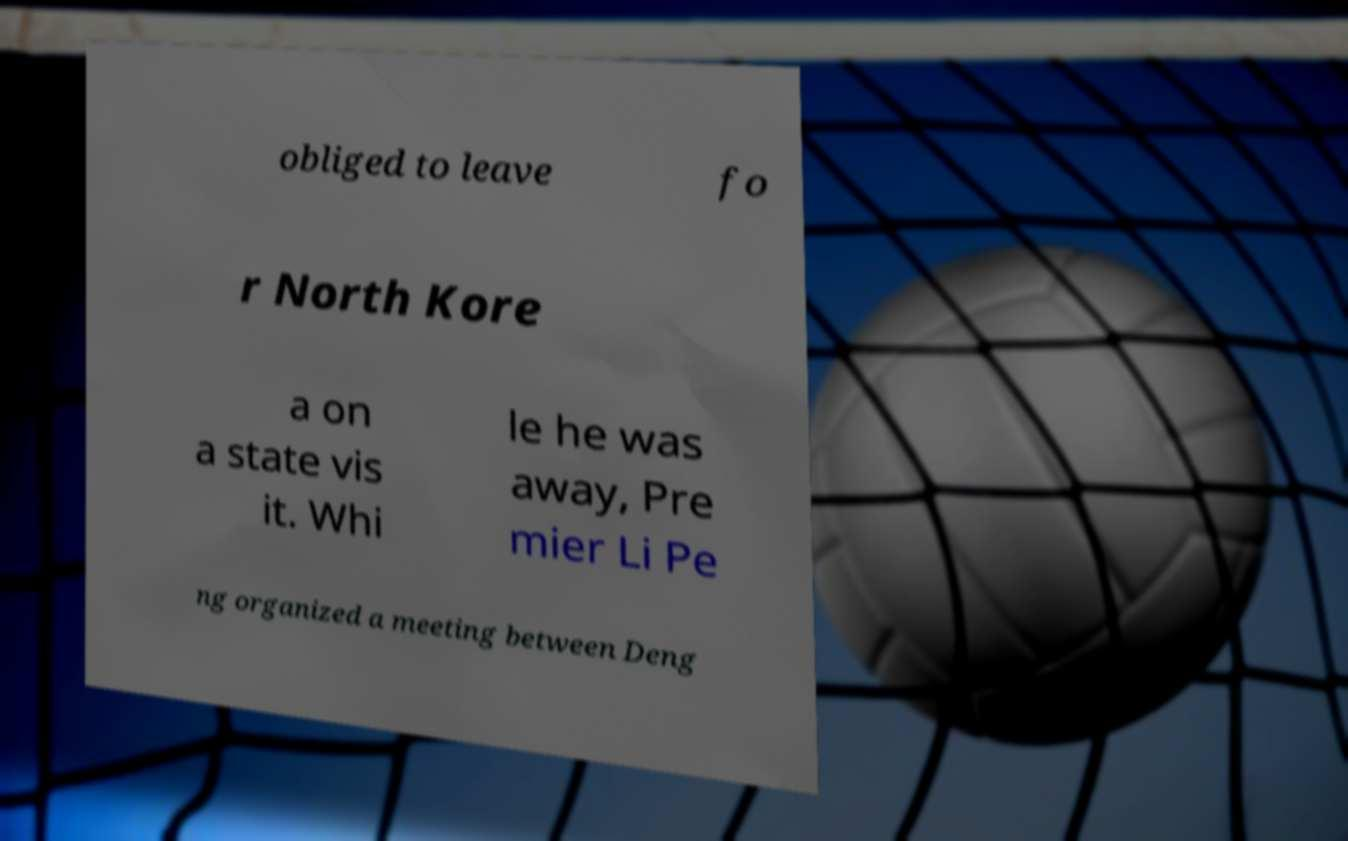There's text embedded in this image that I need extracted. Can you transcribe it verbatim? obliged to leave fo r North Kore a on a state vis it. Whi le he was away, Pre mier Li Pe ng organized a meeting between Deng 